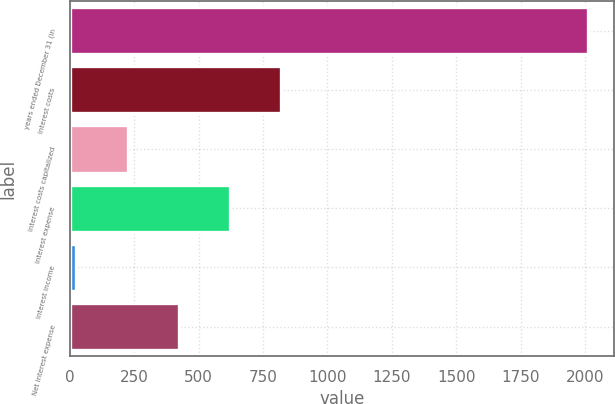Convert chart to OTSL. <chart><loc_0><loc_0><loc_500><loc_500><bar_chart><fcel>years ended December 31 (in<fcel>Interest costs<fcel>Interest costs capitalized<fcel>Interest expense<fcel>Interest income<fcel>Net interest expense<nl><fcel>2012<fcel>820.4<fcel>224.6<fcel>621.8<fcel>26<fcel>423.2<nl></chart> 